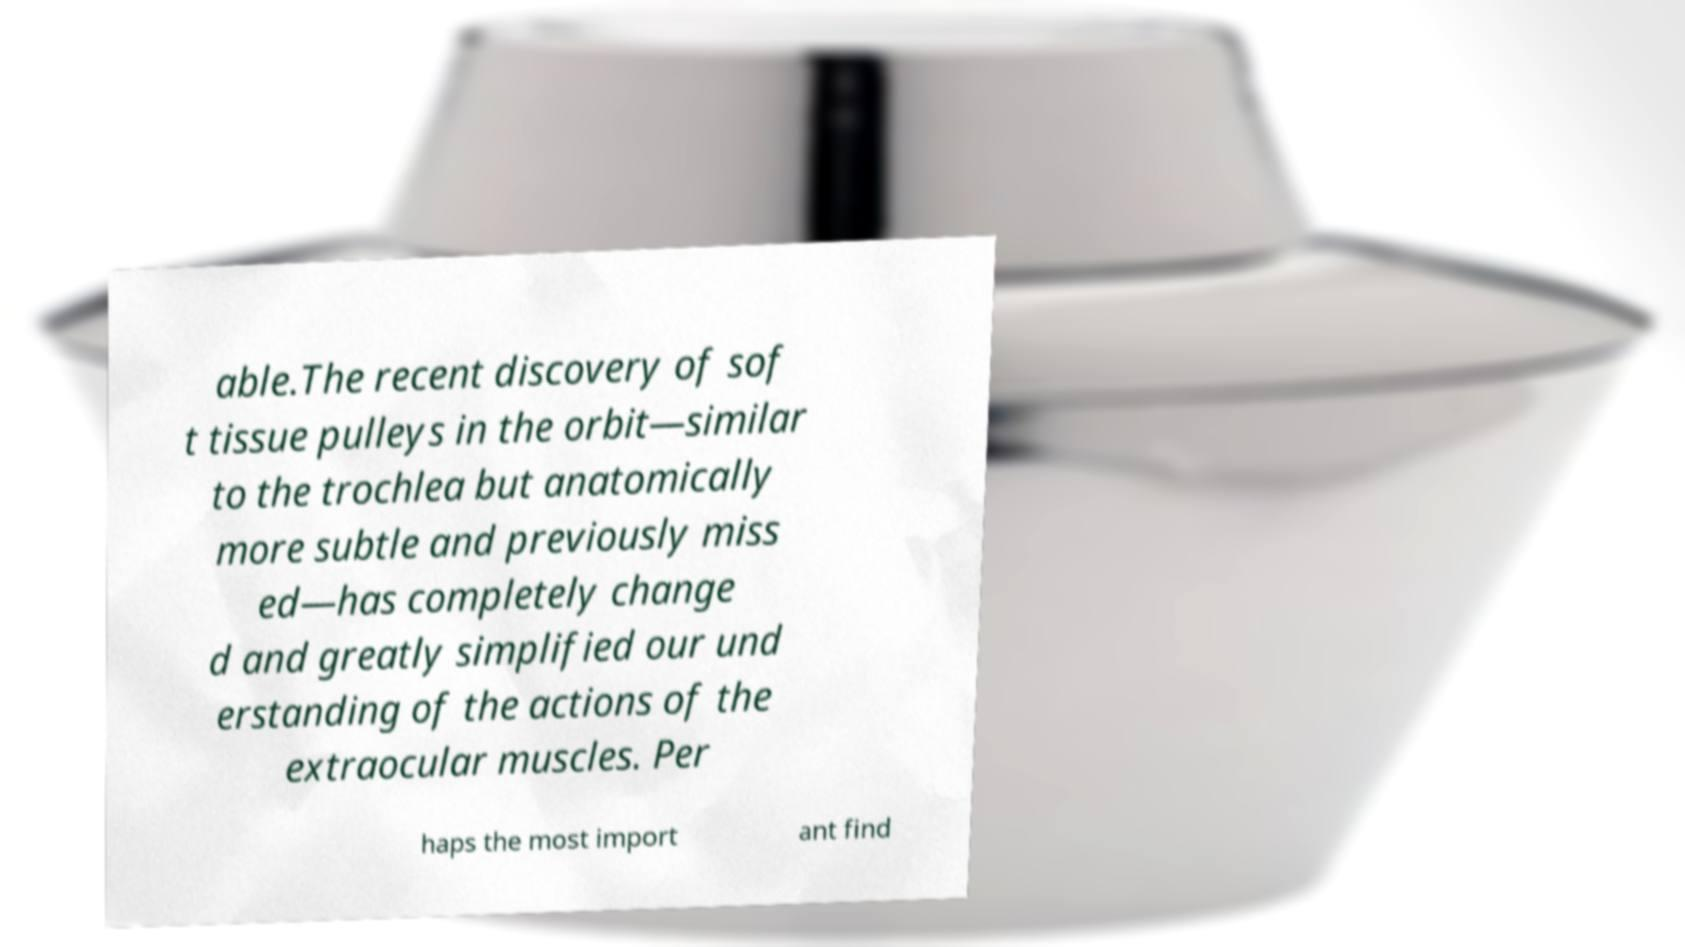Please identify and transcribe the text found in this image. able.The recent discovery of sof t tissue pulleys in the orbit—similar to the trochlea but anatomically more subtle and previously miss ed—has completely change d and greatly simplified our und erstanding of the actions of the extraocular muscles. Per haps the most import ant find 